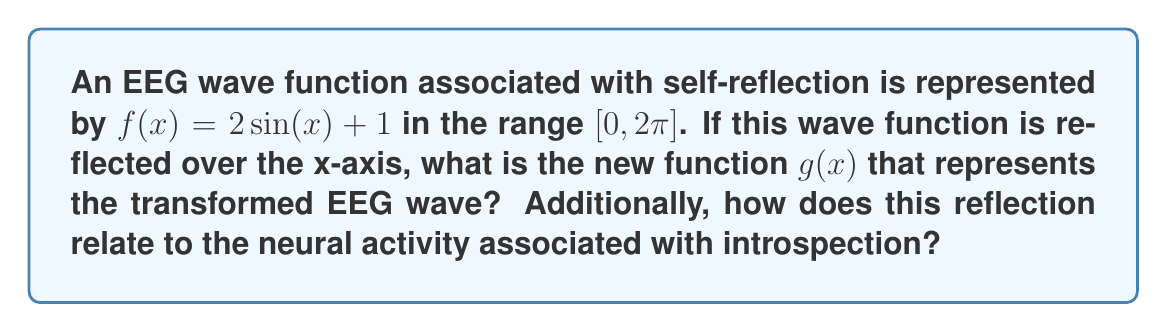Help me with this question. To solve this problem, we'll follow these steps:

1) The general form for reflecting a function over the x-axis is:
   $g(x) = -f(x)$

2) Our original function is $f(x) = 2\sin(x) + 1$

3) Applying the reflection:
   $g(x) = -(2\sin(x) + 1)$

4) Simplifying:
   $g(x) = -2\sin(x) - 1$

5) We can verify this graphically:
   [asy]
   import graph;
   size(200,200);
   
   real f(real x) {return 2*sin(x)+1;}
   real g(real x) {return -2*sin(x)-1;}
   
   draw(graph(f,0,2*pi),blue);
   draw(graph(g,0,2*pi),red);
   
   xaxis("x",Arrow);
   yaxis("y",Arrow);
   
   label("f(x)",(-0.5,2),blue);
   label("g(x)",(-0.5,-2),red);
   [/asy]

6) Relating to neural activity: This reflection represents an inversion of the EEG wave pattern. In the context of introspection, it could signify a shift from active self-reflection (positive amplitude) to a more passive or receptive state (negative amplitude). The preserved sinusoidal pattern suggests that the underlying cognitive process remains cyclical, but the phase has been reversed.
Answer: $g(x) = -2\sin(x) - 1$ 